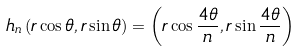<formula> <loc_0><loc_0><loc_500><loc_500>h _ { n } \left ( r \cos \theta , r \sin \theta \right ) = \left ( r \cos \frac { 4 \theta } { n } , r \sin \frac { 4 \theta } { n } \right )</formula> 